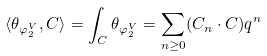<formula> <loc_0><loc_0><loc_500><loc_500>\langle \theta _ { \varphi ^ { V } _ { 2 } } , C \rangle = \int _ { C } \theta _ { \varphi ^ { V } _ { 2 } } = \sum _ { n \geq 0 } ( C _ { n } \cdot C ) q ^ { n }</formula> 